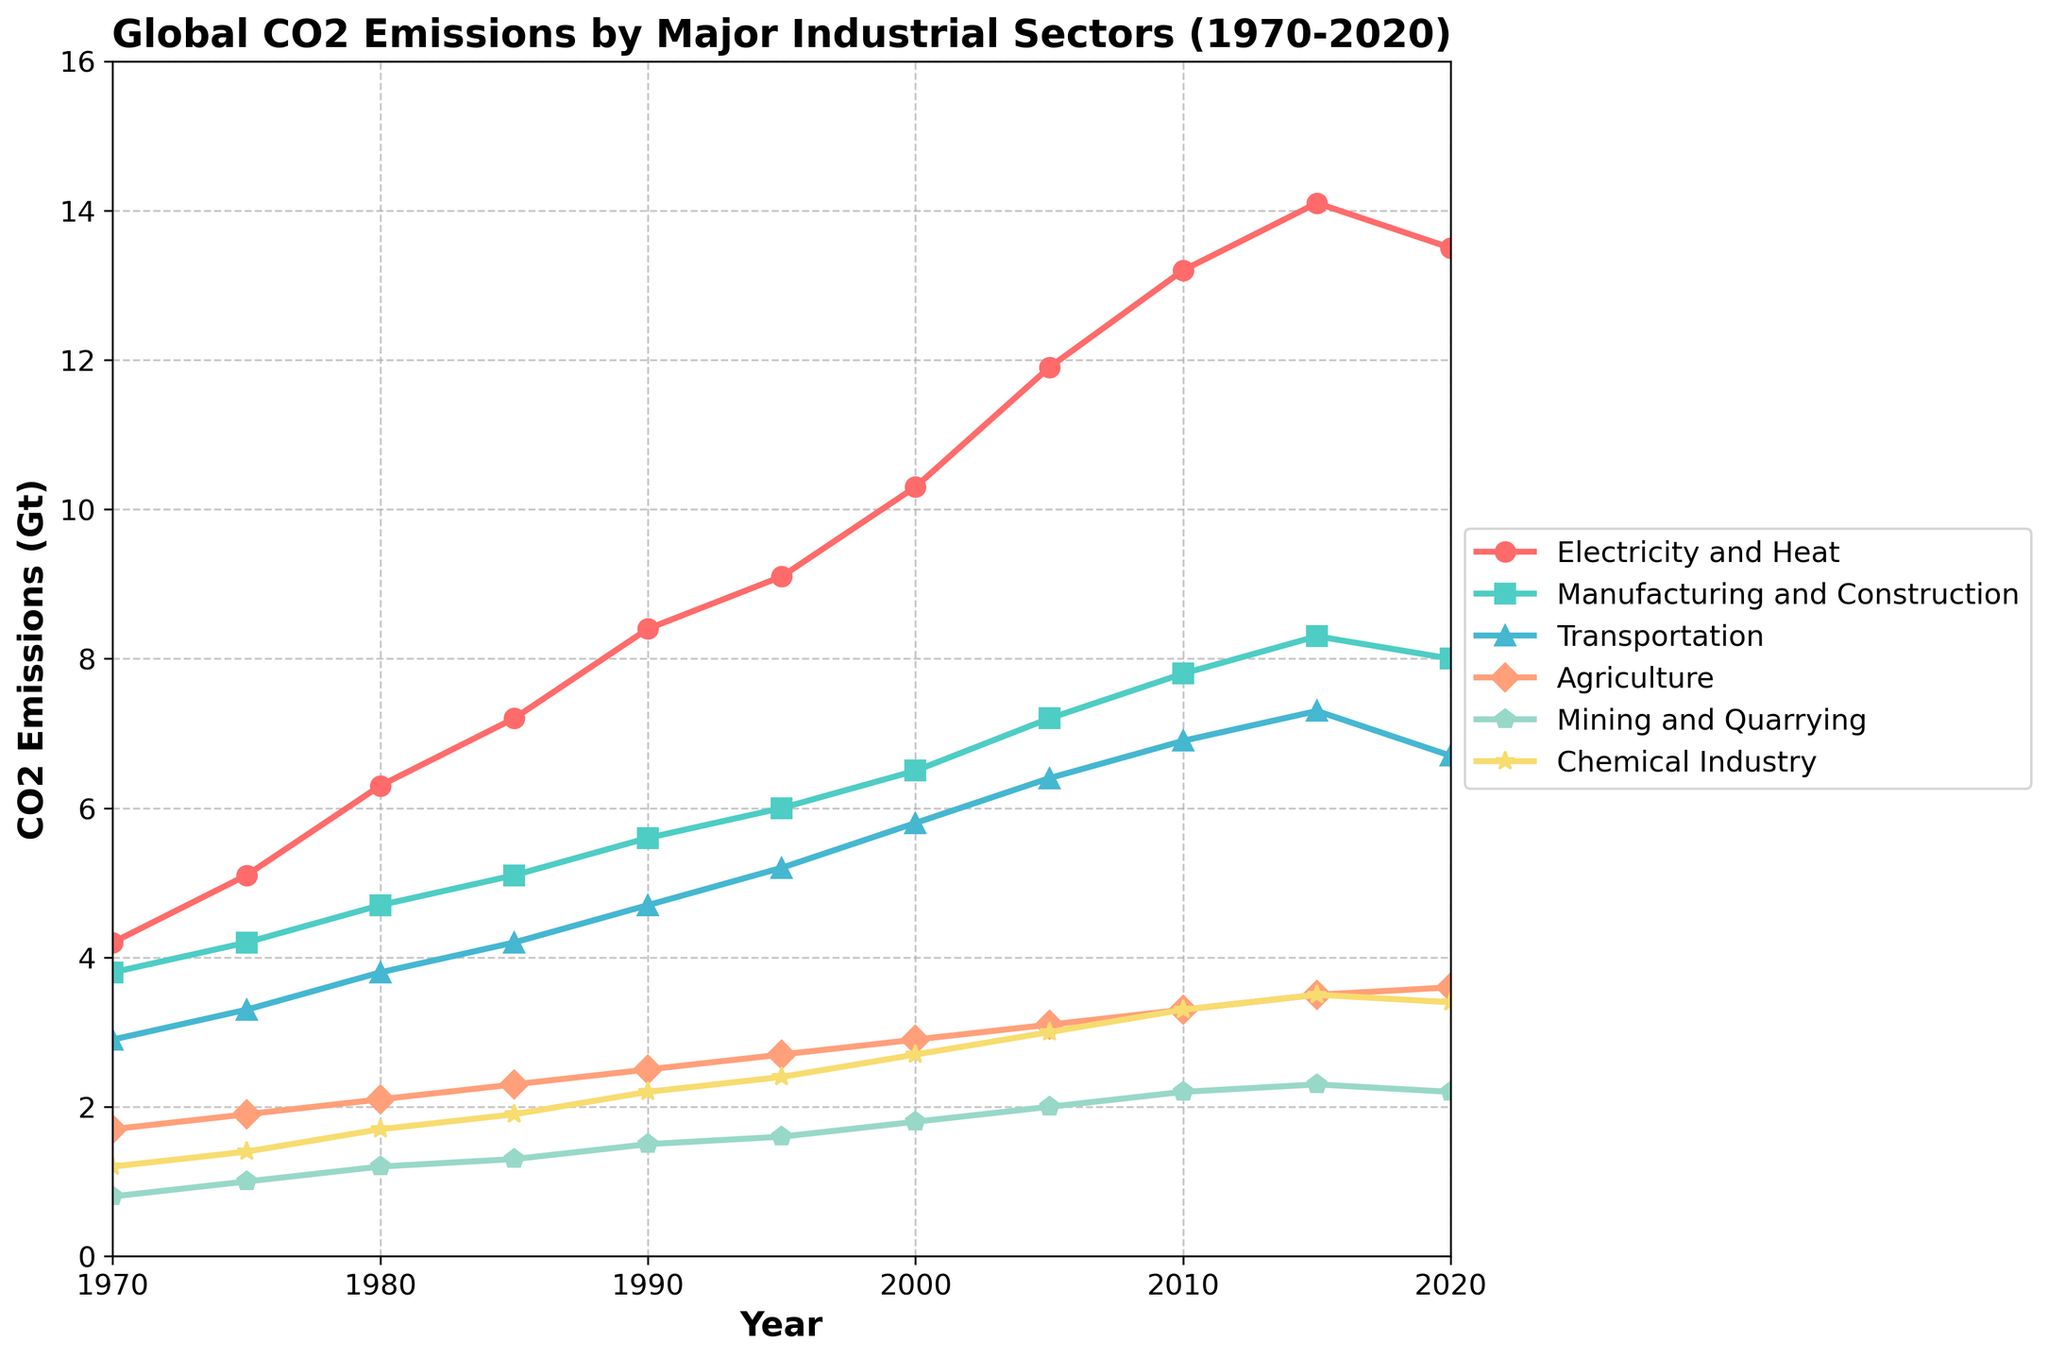When did the CO2 emissions from the Transportation sector peak? By observing the trend line for the Transportation sector, we can identify the highest point which occurs in 2015 with an emission of 7.3 Gt before it starts to decline.
Answer: 2015 Between 1970 and 2020, which sector had the most significant increase in CO2 emissions? By comparing the CO2 emissions from 1970 to 2020 for all sectors, we see that the Electricity and Heat sector increased from 4.2 Gt to 13.5 Gt, showing the largest increase.
Answer: Electricity and Heat How do the CO2 emissions of the Chemical Industry in 1980 compare to those of Mining and Quarrying in 1990? We need to examine the values at the specified years: the Chemical Industry in 1980 had emissions of 1.7 Gt, and Mining and Quarrying in 1990 had emissions of 1.5 Gt. 1.7 Gt is higher than 1.5 Gt.
Answer: Chemical Industry's CO2 emissions were higher What is the total CO2 emissions from the Agriculture sector over the last 50 years? Sum the emission values for the Agriculture sector from 1970 to 2020: 1.7 + 1.9 + 2.1 + 2.3 + 2.5 + 2.7 + 2.9 + 3.1 + 3.3 + 3.5 + 3.6 = 31.6 Gt.
Answer: 31.6 Gt Which sector saw a decrease in CO2 emissions between 2015 and 2020? By checking the emission values for each sector from 2015 to 2020, only the Transportation sector showed a decrease from 7.3 Gt to 6.7 Gt.
Answer: Transportation How did CO2 emissions from Manufacturing and Construction change from 1970 to 1990, compared to the change from 1990 to 2020? First calculate the change from 1970 to 1990: 5.6 Gt - 3.8 Gt = 1.8 Gt. Then calculate the change from 1990 to 2020: 8.0 Gt - 5.6 Gt = 2.4 Gt. Therefore, the change is greater from 1990 to 2020.
Answer: Change was greater from 1990 to 2020 What is the average CO2 emission of the Electricity and Heat sector over the 50-year period? Sum the emissions from 1970 to 2020 for the Electricity and Heat sector and divide by the number of years: (4.2 + 5.1 + 6.3 + 7.2 + 8.4 + 9.1 + 10.3 + 11.9 + 13.2 + 14.1 + 13.5) / 11 = 9.3 Gt.
Answer: 9.3 Gt In which year did the CO2 emissions of the Mining and Quarrying sector exceed 2 Gt for the first time? By examining the trend for the Mining and Quarrying sector, it exceeded 2 Gt for the first time in 2005.
Answer: 2005 